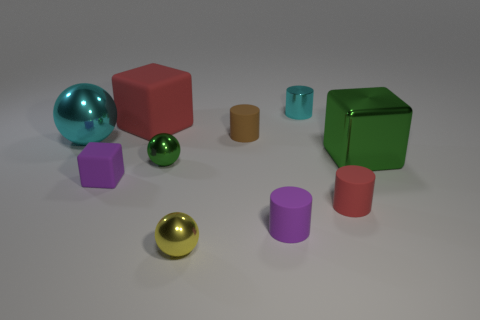Subtract all brown blocks. Subtract all brown balls. How many blocks are left? 3 Subtract all balls. How many objects are left? 7 Subtract all yellow blocks. Subtract all tiny green metallic spheres. How many objects are left? 9 Add 9 large red things. How many large red things are left? 10 Add 10 yellow matte blocks. How many yellow matte blocks exist? 10 Subtract 1 purple cubes. How many objects are left? 9 